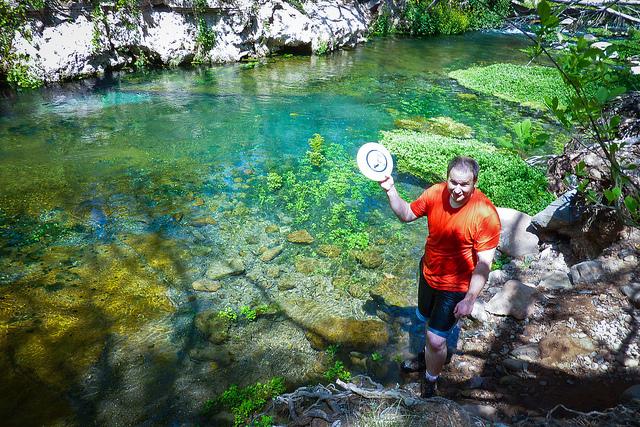What kind of body of water is the man standing next to?
Quick response, please. River. What is this man holding?
Answer briefly. Frisbee. What color is the man's shirt?
Concise answer only. Orange. 